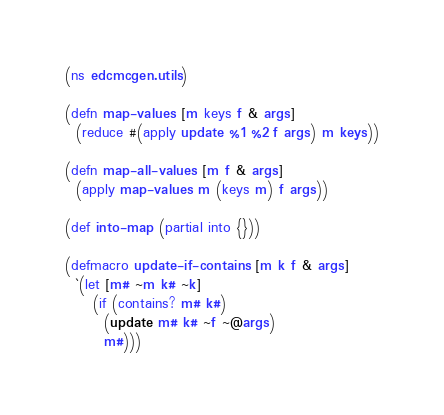<code> <loc_0><loc_0><loc_500><loc_500><_Clojure_>(ns edcmcgen.utils)

(defn map-values [m keys f & args]
  (reduce #(apply update %1 %2 f args) m keys))

(defn map-all-values [m f & args]
  (apply map-values m (keys m) f args))

(def into-map (partial into {}))

(defmacro update-if-contains [m k f & args]
  `(let [m# ~m k# ~k]
     (if (contains? m# k#)
       (update m# k# ~f ~@args)
       m#)))
</code> 